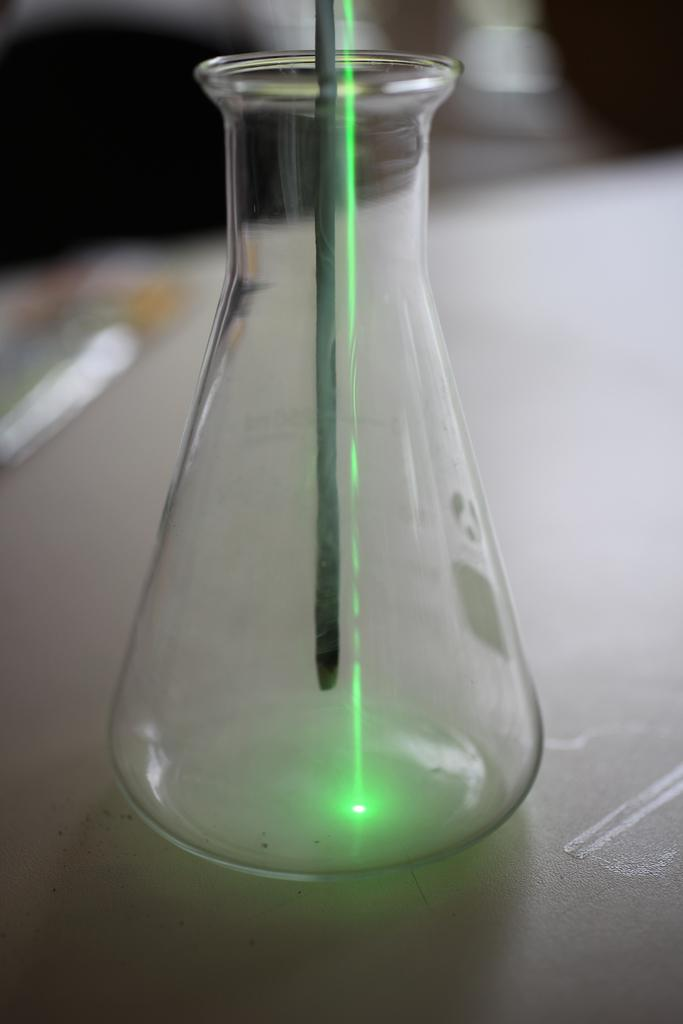What object is placed on the white surface in the image? There is a glass bottle in the image, and it is placed on a white surface. What is the appearance of the glass bottle? The glass bottle is transparent. What can be seen in the middle of the image? There is a rod in the middle of the image. What type of light is visible in the image? Laser light is visible in the image. How would you describe the background of the image? The background of the image has a blurred view. How many cherries are on top of the hat in the image? There are no cherries or hats present in the image. Who is the creator of the glass bottle in the image? The image does not provide information about the creator of the glass bottle. 